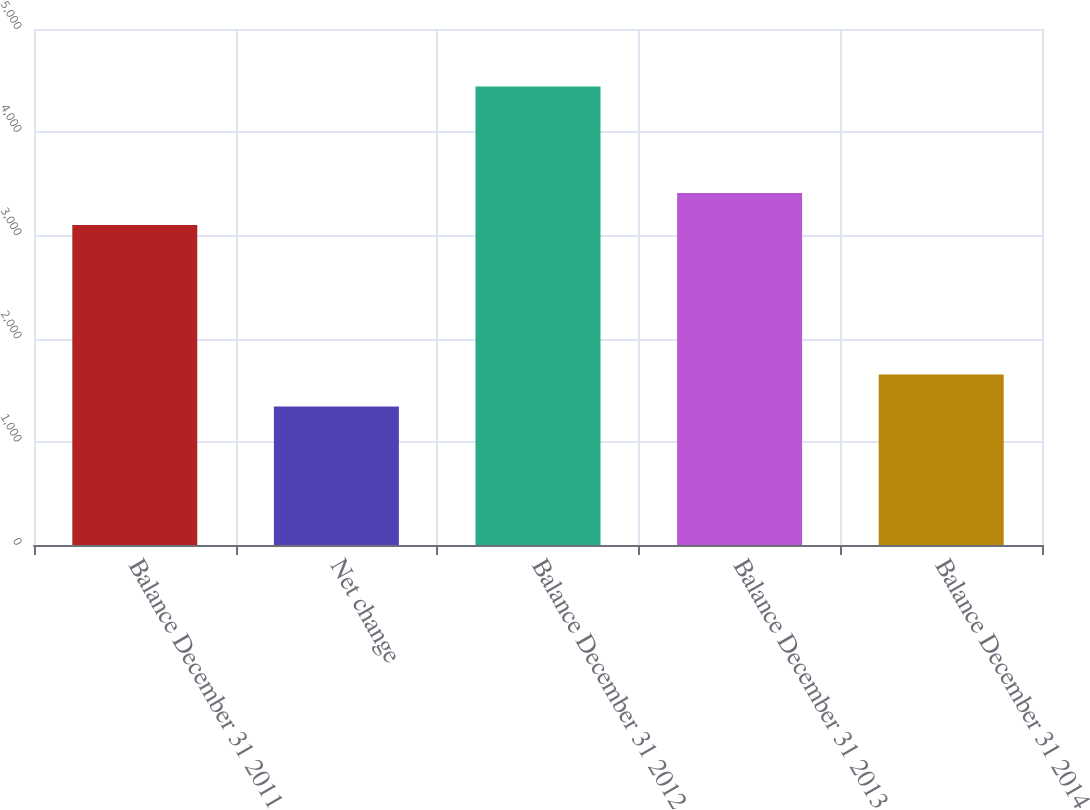<chart> <loc_0><loc_0><loc_500><loc_500><bar_chart><fcel>Balance December 31 2011<fcel>Net change<fcel>Balance December 31 2012<fcel>Balance December 31 2013<fcel>Balance December 31 2014<nl><fcel>3100<fcel>1343<fcel>4443<fcel>3410<fcel>1653<nl></chart> 